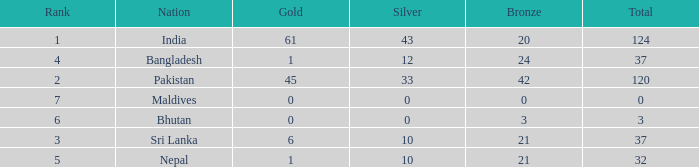How much Silver has a Rank of 7? 1.0. 